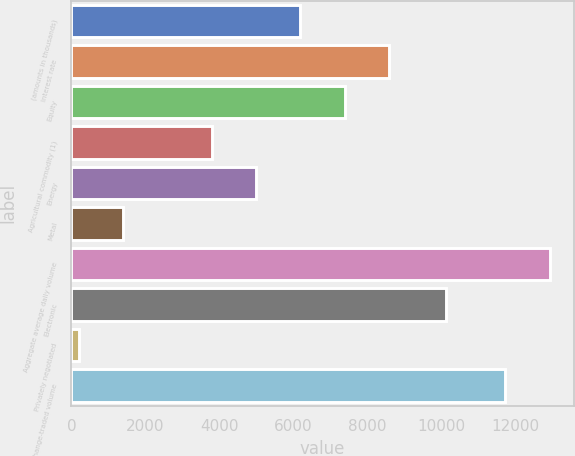Convert chart. <chart><loc_0><loc_0><loc_500><loc_500><bar_chart><fcel>(amounts in thousands)<fcel>Interest rate<fcel>Equity<fcel>Agricultural commodity (1)<fcel>Energy<fcel>Metal<fcel>Aggregate average daily volume<fcel>Electronic<fcel>Privately negotiated<fcel>Total exchange-traded volume<nl><fcel>6182.5<fcel>8576.3<fcel>7379.4<fcel>3788.7<fcel>4985.6<fcel>1394.9<fcel>12916.9<fcel>10120<fcel>198<fcel>11720<nl></chart> 